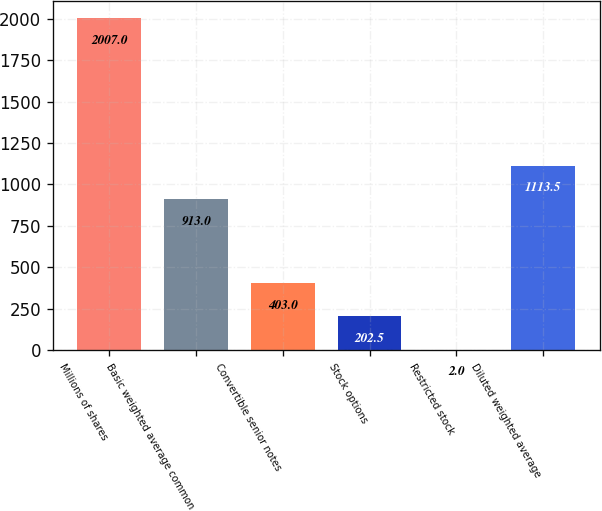<chart> <loc_0><loc_0><loc_500><loc_500><bar_chart><fcel>Millions of shares<fcel>Basic weighted average common<fcel>Convertible senior notes<fcel>Stock options<fcel>Restricted stock<fcel>Diluted weighted average<nl><fcel>2007<fcel>913<fcel>403<fcel>202.5<fcel>2<fcel>1113.5<nl></chart> 